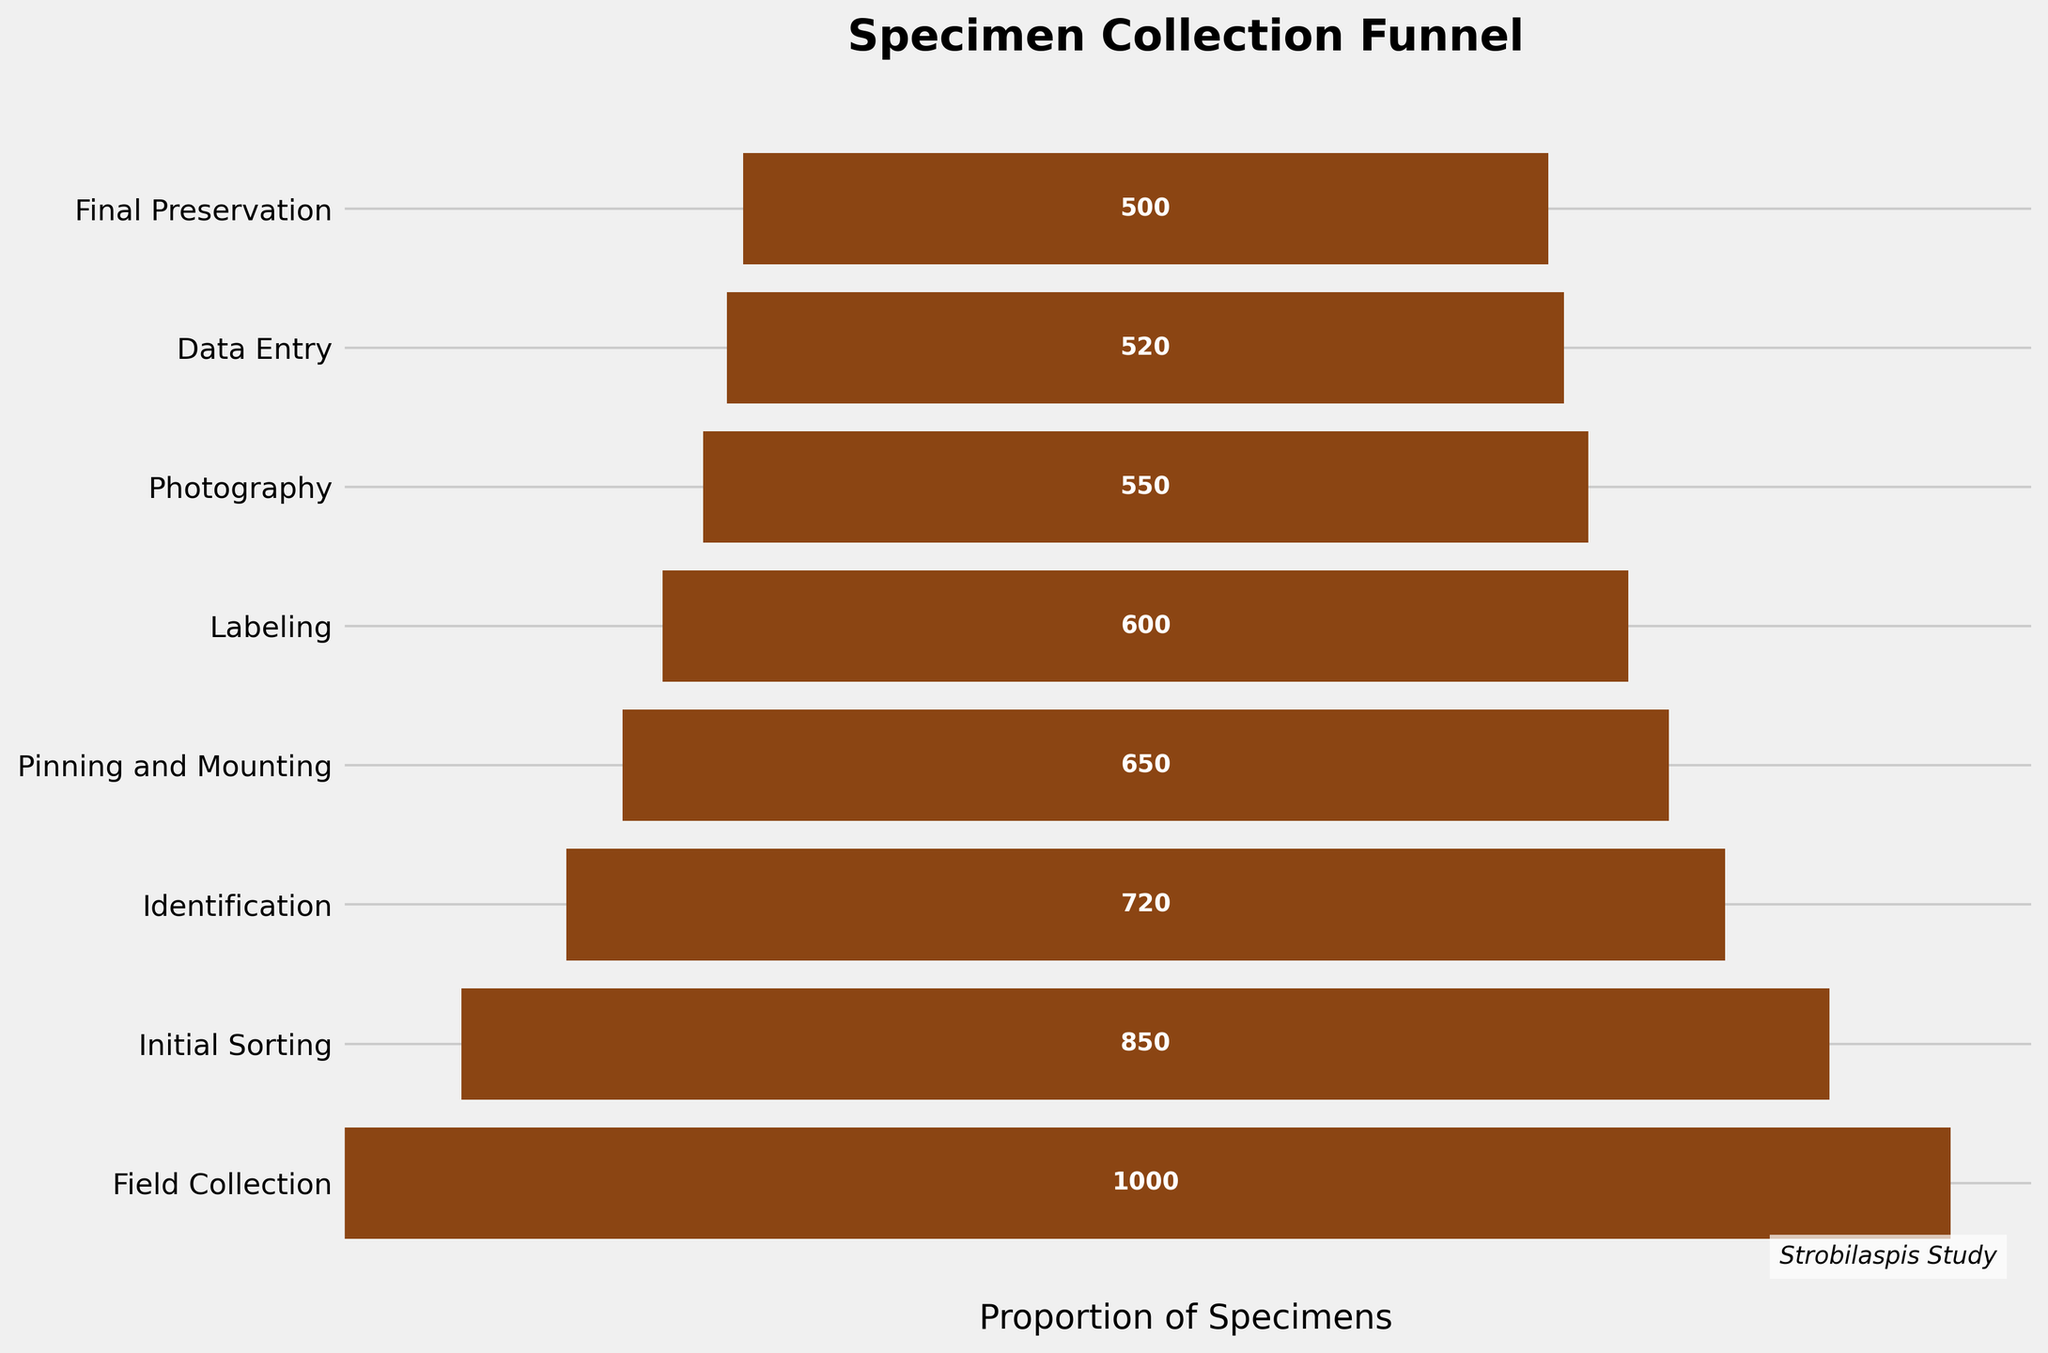What is the title of the figure? The title of a figure is typically displayed at the top of the chart. In this case, it is prominently shown in bold.
Answer: Specimen Collection Funnel How many stages are depicted in the funnel chart? Count the number of horizontal bars or labels on the y-axis, which represent different stages.
Answer: 8 Which stage has the highest number of specimens collected? Identify the stage corresponding to the widest horizontal bar, which has the highest value.
Answer: Field Collection How many specimens are left after the Labeling stage? Locate the Labeling stage on the y-axis and read the value from the label placed on the bar.
Answer: 600 What is the difference in the number of specimens between the Field Collection and Final Preservation stages? Subtract the number of specimens in the Final Preservation stage from the number in the Field Collection stage: 1000 - 500.
Answer: 500 How many stages have more than 500 specimens? Identify the stages where the specimen count is greater than 500 by checking each horizontal bar's label.
Answer: 5 What percentage of specimens remain after the Pinning and Mounting stage compared to the initial count? Calculate the percentage of specimens remaining: (650 / 1000) * 100%.
Answer: 65% Which stage shows the greatest drop in specimen count? Review the differences between specimen counts at each consecutive stage from the chart and identify the largest drop.
Answer: Field Collection to Initial Sorting By how many specimens does the number decrease from Identification to Photography? Subtract the number of specimens in the Photography stage from the Identification stage: 720 - 550.
Answer: 170 What is the average number of specimens from Initial Sorting to Final Preservation stages? Calculate the sum of specimen counts from these stages and divide by the number of stages: (850 + 720 + 650 + 600 + 550 + 520 + 500) / 7.
Answer: 627.14 